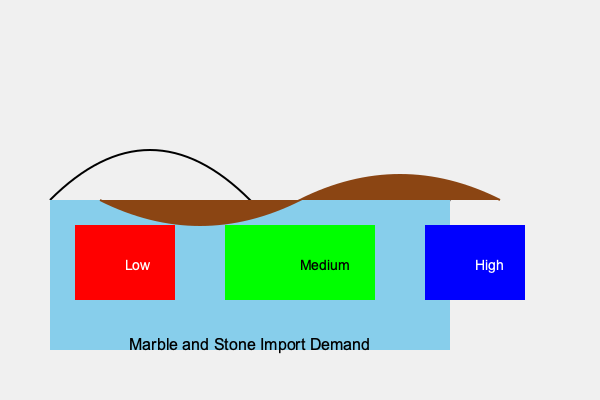Based on the world map showing marble and stone import demand, which region presents the most promising market for an Italian marble and stone exporter looking to expand their business overseas? To determine the most promising market for an Italian marble and stone exporter, we need to analyze the color-coded regions on the world map:

1. The map shows three distinct regions with different colors:
   - Red region (left): Labeled as "Low" demand
   - Green region (middle): Labeled as "Medium" demand
   - Blue region (right): Labeled as "High" demand

2. As an exporter, we want to focus on markets with the highest demand for our products.

3. The color coding indicates the level of import demand for marble and stone in each region:
   - Red signifies low demand
   - Green signifies medium demand
   - Blue signifies high demand

4. The blue region, labeled "High," represents the area with the highest import demand for marble and stone.

5. For an Italian marble and stone exporter looking to expand their business overseas, the region with the highest demand would offer the most promising opportunities.

6. Therefore, the blue region, indicating high import demand, would be the most attractive market for expansion.
Answer: The blue (high demand) region 